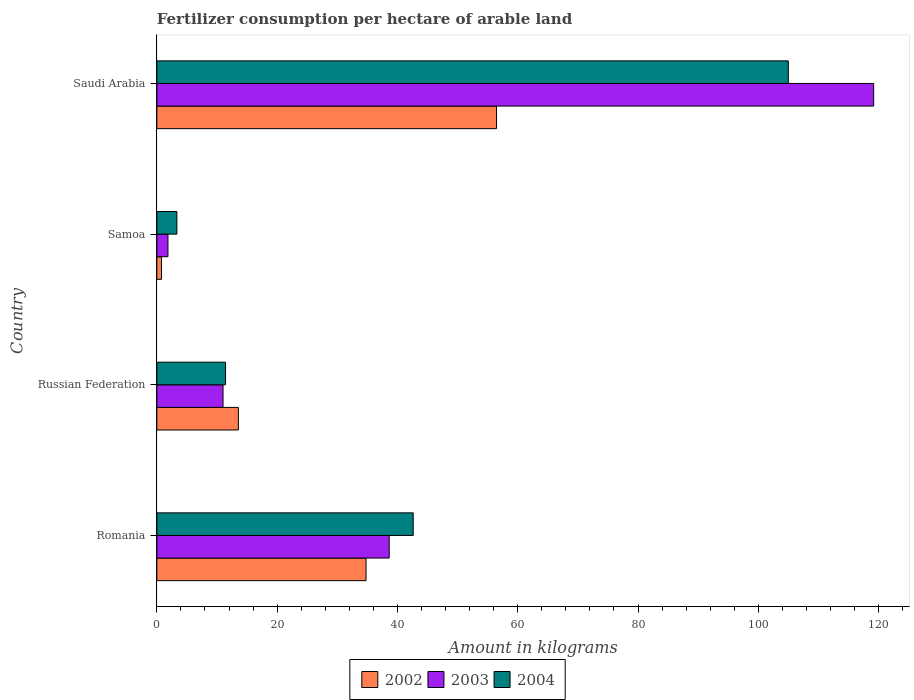How many different coloured bars are there?
Ensure brevity in your answer.  3. How many groups of bars are there?
Your response must be concise. 4. Are the number of bars per tick equal to the number of legend labels?
Provide a short and direct response. Yes. Are the number of bars on each tick of the Y-axis equal?
Your response must be concise. Yes. What is the label of the 2nd group of bars from the top?
Provide a succinct answer. Samoa. What is the amount of fertilizer consumption in 2004 in Samoa?
Give a very brief answer. 3.33. Across all countries, what is the maximum amount of fertilizer consumption in 2002?
Your answer should be compact. 56.48. Across all countries, what is the minimum amount of fertilizer consumption in 2003?
Offer a terse response. 1.85. In which country was the amount of fertilizer consumption in 2002 maximum?
Offer a very short reply. Saudi Arabia. In which country was the amount of fertilizer consumption in 2002 minimum?
Give a very brief answer. Samoa. What is the total amount of fertilizer consumption in 2002 in the graph?
Offer a terse response. 105.58. What is the difference between the amount of fertilizer consumption in 2002 in Romania and that in Samoa?
Ensure brevity in your answer.  34.01. What is the difference between the amount of fertilizer consumption in 2004 in Romania and the amount of fertilizer consumption in 2003 in Saudi Arabia?
Ensure brevity in your answer.  -76.56. What is the average amount of fertilizer consumption in 2004 per country?
Provide a succinct answer. 40.59. What is the difference between the amount of fertilizer consumption in 2002 and amount of fertilizer consumption in 2004 in Samoa?
Offer a very short reply. -2.56. In how many countries, is the amount of fertilizer consumption in 2004 greater than 56 kg?
Make the answer very short. 1. What is the ratio of the amount of fertilizer consumption in 2002 in Samoa to that in Saudi Arabia?
Provide a short and direct response. 0.01. What is the difference between the highest and the second highest amount of fertilizer consumption in 2004?
Give a very brief answer. 62.37. What is the difference between the highest and the lowest amount of fertilizer consumption in 2003?
Your answer should be compact. 117.34. In how many countries, is the amount of fertilizer consumption in 2003 greater than the average amount of fertilizer consumption in 2003 taken over all countries?
Your answer should be compact. 1. What does the 3rd bar from the top in Russian Federation represents?
Offer a terse response. 2002. Is it the case that in every country, the sum of the amount of fertilizer consumption in 2003 and amount of fertilizer consumption in 2002 is greater than the amount of fertilizer consumption in 2004?
Your answer should be very brief. No. How many bars are there?
Your response must be concise. 12. Are all the bars in the graph horizontal?
Keep it short and to the point. Yes. How many countries are there in the graph?
Make the answer very short. 4. What is the difference between two consecutive major ticks on the X-axis?
Your answer should be compact. 20. Does the graph contain grids?
Provide a succinct answer. No. Where does the legend appear in the graph?
Provide a succinct answer. Bottom center. How many legend labels are there?
Your answer should be very brief. 3. How are the legend labels stacked?
Give a very brief answer. Horizontal. What is the title of the graph?
Keep it short and to the point. Fertilizer consumption per hectare of arable land. What is the label or title of the X-axis?
Your response must be concise. Amount in kilograms. What is the label or title of the Y-axis?
Provide a succinct answer. Country. What is the Amount in kilograms in 2002 in Romania?
Offer a terse response. 34.78. What is the Amount in kilograms in 2003 in Romania?
Your response must be concise. 38.63. What is the Amount in kilograms of 2004 in Romania?
Your answer should be very brief. 42.63. What is the Amount in kilograms in 2002 in Russian Federation?
Provide a short and direct response. 13.55. What is the Amount in kilograms of 2003 in Russian Federation?
Your answer should be compact. 11. What is the Amount in kilograms in 2004 in Russian Federation?
Keep it short and to the point. 11.42. What is the Amount in kilograms of 2002 in Samoa?
Give a very brief answer. 0.77. What is the Amount in kilograms of 2003 in Samoa?
Ensure brevity in your answer.  1.85. What is the Amount in kilograms in 2004 in Samoa?
Make the answer very short. 3.33. What is the Amount in kilograms in 2002 in Saudi Arabia?
Make the answer very short. 56.48. What is the Amount in kilograms of 2003 in Saudi Arabia?
Your answer should be very brief. 119.18. What is the Amount in kilograms of 2004 in Saudi Arabia?
Provide a succinct answer. 104.99. Across all countries, what is the maximum Amount in kilograms of 2002?
Your answer should be compact. 56.48. Across all countries, what is the maximum Amount in kilograms in 2003?
Your answer should be very brief. 119.18. Across all countries, what is the maximum Amount in kilograms of 2004?
Give a very brief answer. 104.99. Across all countries, what is the minimum Amount in kilograms of 2002?
Provide a succinct answer. 0.77. Across all countries, what is the minimum Amount in kilograms of 2003?
Make the answer very short. 1.85. Across all countries, what is the minimum Amount in kilograms of 2004?
Give a very brief answer. 3.33. What is the total Amount in kilograms of 2002 in the graph?
Ensure brevity in your answer.  105.58. What is the total Amount in kilograms of 2003 in the graph?
Offer a terse response. 170.66. What is the total Amount in kilograms of 2004 in the graph?
Your response must be concise. 162.37. What is the difference between the Amount in kilograms in 2002 in Romania and that in Russian Federation?
Make the answer very short. 21.23. What is the difference between the Amount in kilograms of 2003 in Romania and that in Russian Federation?
Offer a terse response. 27.63. What is the difference between the Amount in kilograms in 2004 in Romania and that in Russian Federation?
Offer a very short reply. 31.21. What is the difference between the Amount in kilograms of 2002 in Romania and that in Samoa?
Your answer should be very brief. 34.01. What is the difference between the Amount in kilograms of 2003 in Romania and that in Samoa?
Make the answer very short. 36.79. What is the difference between the Amount in kilograms of 2004 in Romania and that in Samoa?
Provide a short and direct response. 39.29. What is the difference between the Amount in kilograms of 2002 in Romania and that in Saudi Arabia?
Your answer should be compact. -21.7. What is the difference between the Amount in kilograms of 2003 in Romania and that in Saudi Arabia?
Your response must be concise. -80.55. What is the difference between the Amount in kilograms of 2004 in Romania and that in Saudi Arabia?
Offer a terse response. -62.37. What is the difference between the Amount in kilograms in 2002 in Russian Federation and that in Samoa?
Provide a succinct answer. 12.78. What is the difference between the Amount in kilograms of 2003 in Russian Federation and that in Samoa?
Your answer should be very brief. 9.16. What is the difference between the Amount in kilograms of 2004 in Russian Federation and that in Samoa?
Your answer should be compact. 8.09. What is the difference between the Amount in kilograms in 2002 in Russian Federation and that in Saudi Arabia?
Make the answer very short. -42.93. What is the difference between the Amount in kilograms in 2003 in Russian Federation and that in Saudi Arabia?
Offer a terse response. -108.18. What is the difference between the Amount in kilograms of 2004 in Russian Federation and that in Saudi Arabia?
Provide a succinct answer. -93.57. What is the difference between the Amount in kilograms of 2002 in Samoa and that in Saudi Arabia?
Ensure brevity in your answer.  -55.71. What is the difference between the Amount in kilograms in 2003 in Samoa and that in Saudi Arabia?
Ensure brevity in your answer.  -117.34. What is the difference between the Amount in kilograms of 2004 in Samoa and that in Saudi Arabia?
Your response must be concise. -101.66. What is the difference between the Amount in kilograms of 2002 in Romania and the Amount in kilograms of 2003 in Russian Federation?
Provide a short and direct response. 23.78. What is the difference between the Amount in kilograms in 2002 in Romania and the Amount in kilograms in 2004 in Russian Federation?
Make the answer very short. 23.36. What is the difference between the Amount in kilograms of 2003 in Romania and the Amount in kilograms of 2004 in Russian Federation?
Offer a terse response. 27.21. What is the difference between the Amount in kilograms of 2002 in Romania and the Amount in kilograms of 2003 in Samoa?
Offer a terse response. 32.94. What is the difference between the Amount in kilograms of 2002 in Romania and the Amount in kilograms of 2004 in Samoa?
Your response must be concise. 31.45. What is the difference between the Amount in kilograms in 2003 in Romania and the Amount in kilograms in 2004 in Samoa?
Your answer should be compact. 35.3. What is the difference between the Amount in kilograms in 2002 in Romania and the Amount in kilograms in 2003 in Saudi Arabia?
Ensure brevity in your answer.  -84.4. What is the difference between the Amount in kilograms in 2002 in Romania and the Amount in kilograms in 2004 in Saudi Arabia?
Provide a short and direct response. -70.21. What is the difference between the Amount in kilograms in 2003 in Romania and the Amount in kilograms in 2004 in Saudi Arabia?
Keep it short and to the point. -66.36. What is the difference between the Amount in kilograms in 2002 in Russian Federation and the Amount in kilograms in 2003 in Samoa?
Give a very brief answer. 11.71. What is the difference between the Amount in kilograms in 2002 in Russian Federation and the Amount in kilograms in 2004 in Samoa?
Offer a terse response. 10.22. What is the difference between the Amount in kilograms of 2003 in Russian Federation and the Amount in kilograms of 2004 in Samoa?
Keep it short and to the point. 7.67. What is the difference between the Amount in kilograms in 2002 in Russian Federation and the Amount in kilograms in 2003 in Saudi Arabia?
Your response must be concise. -105.63. What is the difference between the Amount in kilograms of 2002 in Russian Federation and the Amount in kilograms of 2004 in Saudi Arabia?
Provide a succinct answer. -91.44. What is the difference between the Amount in kilograms of 2003 in Russian Federation and the Amount in kilograms of 2004 in Saudi Arabia?
Provide a short and direct response. -93.99. What is the difference between the Amount in kilograms of 2002 in Samoa and the Amount in kilograms of 2003 in Saudi Arabia?
Your answer should be very brief. -118.41. What is the difference between the Amount in kilograms in 2002 in Samoa and the Amount in kilograms in 2004 in Saudi Arabia?
Keep it short and to the point. -104.22. What is the difference between the Amount in kilograms of 2003 in Samoa and the Amount in kilograms of 2004 in Saudi Arabia?
Ensure brevity in your answer.  -103.15. What is the average Amount in kilograms in 2002 per country?
Make the answer very short. 26.4. What is the average Amount in kilograms in 2003 per country?
Make the answer very short. 42.67. What is the average Amount in kilograms of 2004 per country?
Give a very brief answer. 40.59. What is the difference between the Amount in kilograms of 2002 and Amount in kilograms of 2003 in Romania?
Provide a succinct answer. -3.85. What is the difference between the Amount in kilograms of 2002 and Amount in kilograms of 2004 in Romania?
Give a very brief answer. -7.84. What is the difference between the Amount in kilograms of 2003 and Amount in kilograms of 2004 in Romania?
Provide a succinct answer. -3.99. What is the difference between the Amount in kilograms of 2002 and Amount in kilograms of 2003 in Russian Federation?
Make the answer very short. 2.55. What is the difference between the Amount in kilograms of 2002 and Amount in kilograms of 2004 in Russian Federation?
Give a very brief answer. 2.13. What is the difference between the Amount in kilograms in 2003 and Amount in kilograms in 2004 in Russian Federation?
Ensure brevity in your answer.  -0.42. What is the difference between the Amount in kilograms of 2002 and Amount in kilograms of 2003 in Samoa?
Offer a terse response. -1.08. What is the difference between the Amount in kilograms of 2002 and Amount in kilograms of 2004 in Samoa?
Keep it short and to the point. -2.56. What is the difference between the Amount in kilograms of 2003 and Amount in kilograms of 2004 in Samoa?
Provide a succinct answer. -1.49. What is the difference between the Amount in kilograms of 2002 and Amount in kilograms of 2003 in Saudi Arabia?
Provide a short and direct response. -62.7. What is the difference between the Amount in kilograms in 2002 and Amount in kilograms in 2004 in Saudi Arabia?
Ensure brevity in your answer.  -48.51. What is the difference between the Amount in kilograms in 2003 and Amount in kilograms in 2004 in Saudi Arabia?
Keep it short and to the point. 14.19. What is the ratio of the Amount in kilograms in 2002 in Romania to that in Russian Federation?
Your response must be concise. 2.57. What is the ratio of the Amount in kilograms of 2003 in Romania to that in Russian Federation?
Make the answer very short. 3.51. What is the ratio of the Amount in kilograms of 2004 in Romania to that in Russian Federation?
Provide a succinct answer. 3.73. What is the ratio of the Amount in kilograms in 2002 in Romania to that in Samoa?
Make the answer very short. 45.22. What is the ratio of the Amount in kilograms of 2003 in Romania to that in Samoa?
Give a very brief answer. 20.93. What is the ratio of the Amount in kilograms in 2004 in Romania to that in Samoa?
Provide a short and direct response. 12.79. What is the ratio of the Amount in kilograms in 2002 in Romania to that in Saudi Arabia?
Give a very brief answer. 0.62. What is the ratio of the Amount in kilograms of 2003 in Romania to that in Saudi Arabia?
Keep it short and to the point. 0.32. What is the ratio of the Amount in kilograms of 2004 in Romania to that in Saudi Arabia?
Keep it short and to the point. 0.41. What is the ratio of the Amount in kilograms of 2002 in Russian Federation to that in Samoa?
Give a very brief answer. 17.62. What is the ratio of the Amount in kilograms in 2003 in Russian Federation to that in Samoa?
Provide a succinct answer. 5.96. What is the ratio of the Amount in kilograms in 2004 in Russian Federation to that in Samoa?
Your response must be concise. 3.43. What is the ratio of the Amount in kilograms in 2002 in Russian Federation to that in Saudi Arabia?
Offer a terse response. 0.24. What is the ratio of the Amount in kilograms in 2003 in Russian Federation to that in Saudi Arabia?
Give a very brief answer. 0.09. What is the ratio of the Amount in kilograms in 2004 in Russian Federation to that in Saudi Arabia?
Your answer should be compact. 0.11. What is the ratio of the Amount in kilograms in 2002 in Samoa to that in Saudi Arabia?
Your response must be concise. 0.01. What is the ratio of the Amount in kilograms of 2003 in Samoa to that in Saudi Arabia?
Keep it short and to the point. 0.02. What is the ratio of the Amount in kilograms of 2004 in Samoa to that in Saudi Arabia?
Your answer should be very brief. 0.03. What is the difference between the highest and the second highest Amount in kilograms in 2002?
Your answer should be compact. 21.7. What is the difference between the highest and the second highest Amount in kilograms of 2003?
Provide a short and direct response. 80.55. What is the difference between the highest and the second highest Amount in kilograms in 2004?
Make the answer very short. 62.37. What is the difference between the highest and the lowest Amount in kilograms in 2002?
Your response must be concise. 55.71. What is the difference between the highest and the lowest Amount in kilograms of 2003?
Your answer should be very brief. 117.34. What is the difference between the highest and the lowest Amount in kilograms in 2004?
Your answer should be very brief. 101.66. 